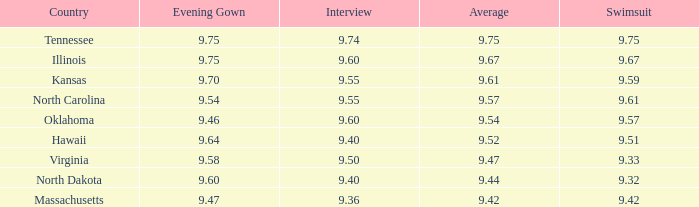What was the average for the country with the swimsuit score of 9.57? 9.54. 